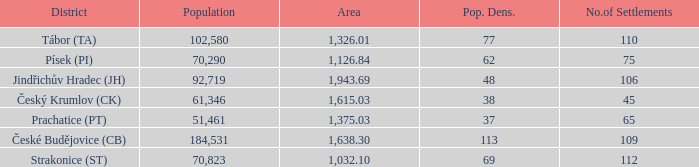How big is the area that has a population density of 113 and a population larger than 184,531? 0.0. 